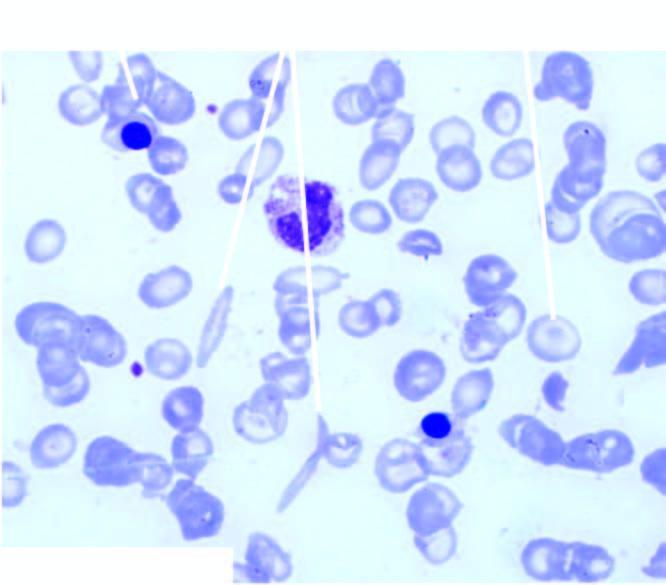does pbf show crescent shaped elongated red blood cells, a few target cells and a few erythroblasts?
Answer the question using a single word or phrase. Yes 